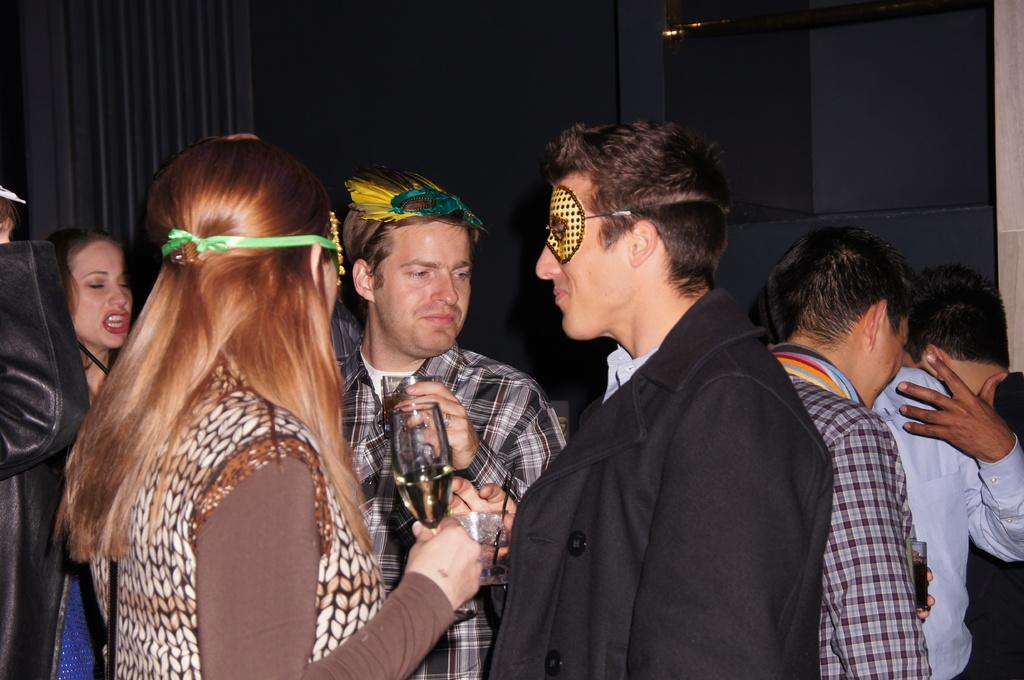What is the woman in the image holding? The woman is holding a glass. What is the person in the image holding? The person is also holding a glass. Can you describe the group of people in the background? There is a group of people standing in the background. What can be seen in the background besides the group of people? There is a curtain in the background. What type of spark can be seen coming from the woman's locket in the image? There is no locket or spark present in the image. How many times does the person in the image sneeze during the scene? There is no indication of sneezing in the image. 